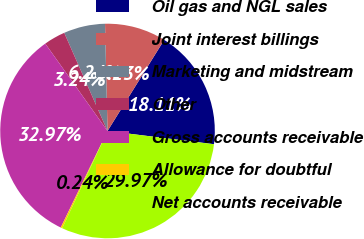Convert chart to OTSL. <chart><loc_0><loc_0><loc_500><loc_500><pie_chart><fcel>Oil gas and NGL sales<fcel>Joint interest billings<fcel>Marketing and midstream<fcel>Other<fcel>Gross accounts receivable<fcel>Allowance for doubtful<fcel>Net accounts receivable<nl><fcel>18.11%<fcel>9.23%<fcel>6.24%<fcel>3.24%<fcel>32.97%<fcel>0.24%<fcel>29.97%<nl></chart> 